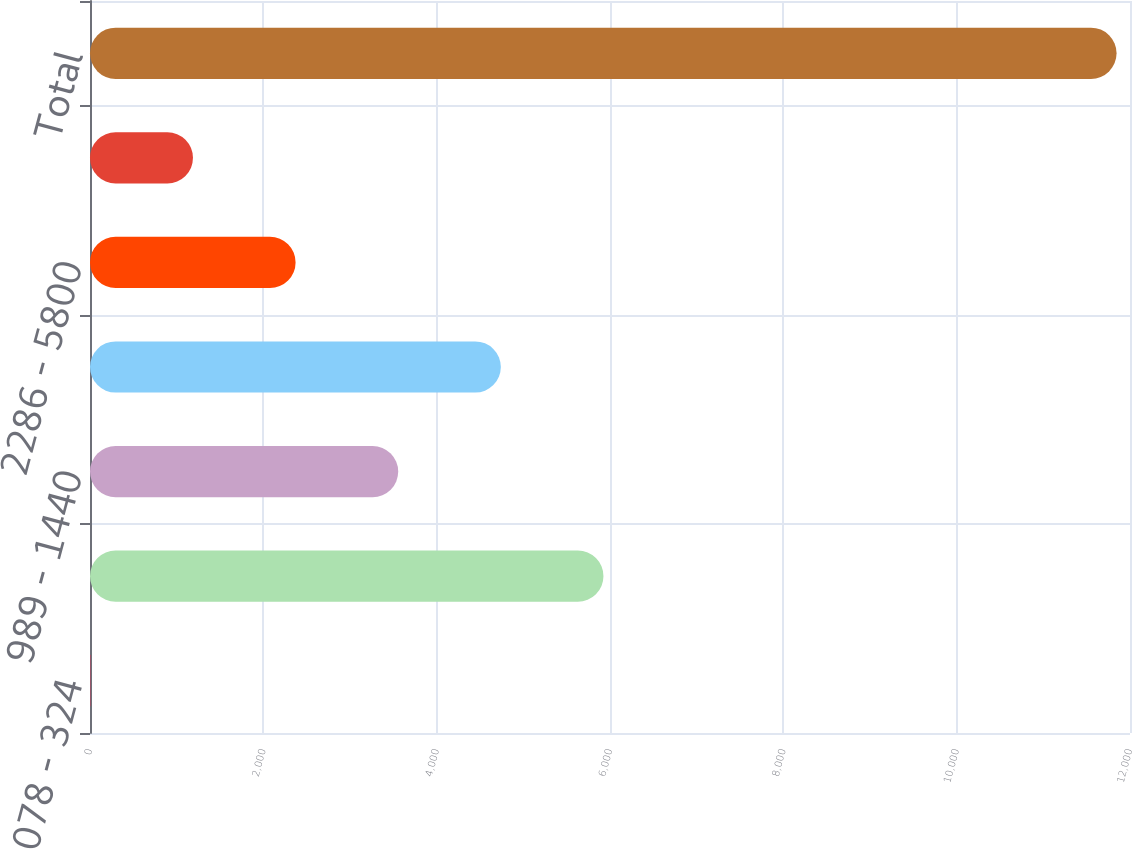Convert chart. <chart><loc_0><loc_0><loc_500><loc_500><bar_chart><fcel>078 - 324<fcel>325 - 988<fcel>989 - 1440<fcel>1441 - 2285<fcel>2286 - 5800<fcel>5801 - 8000<fcel>Total<nl><fcel>4<fcel>5924.5<fcel>3556.3<fcel>4740.4<fcel>2372.2<fcel>1188.1<fcel>11845<nl></chart> 